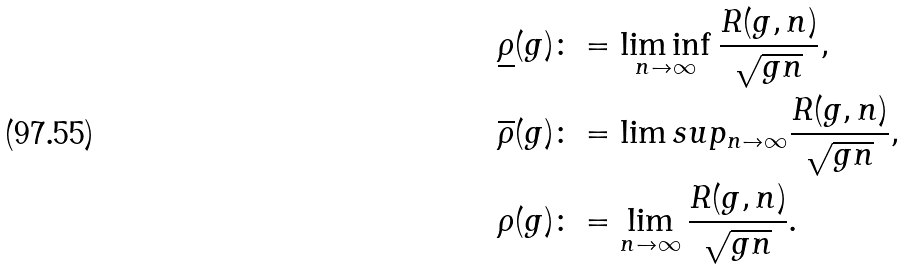<formula> <loc_0><loc_0><loc_500><loc_500>\underline { \rho } ( g ) & \colon = \liminf _ { n \to \infty } \frac { R ( g , n ) } { \sqrt { g n } } , \\ \overline { \rho } ( g ) & \colon = \lim s u p _ { n \to \infty } \frac { R ( g , n ) } { \sqrt { g n } } , \\ \rho ( g ) & \colon = \lim _ { n \to \infty } \frac { R ( g , n ) } { \sqrt { g n } } .</formula> 